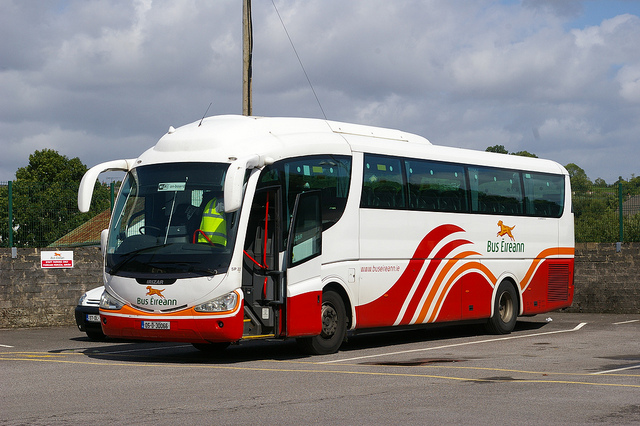Please transcribe the text in this image. Bus 